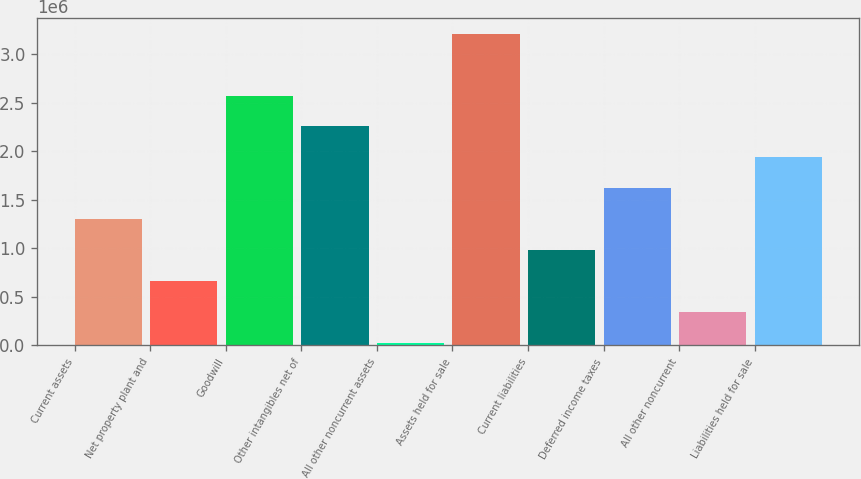Convert chart to OTSL. <chart><loc_0><loc_0><loc_500><loc_500><bar_chart><fcel>Current assets<fcel>Net property plant and<fcel>Goodwill<fcel>Other intangibles net of<fcel>All other noncurrent assets<fcel>Assets held for sale<fcel>Current liabilities<fcel>Deferred income taxes<fcel>All other noncurrent<fcel>Liabilities held for sale<nl><fcel>1.29879e+06<fcel>662080<fcel>2.5722e+06<fcel>2.25384e+06<fcel>25374<fcel>3.2089e+06<fcel>980432<fcel>1.61714e+06<fcel>343727<fcel>1.93549e+06<nl></chart> 